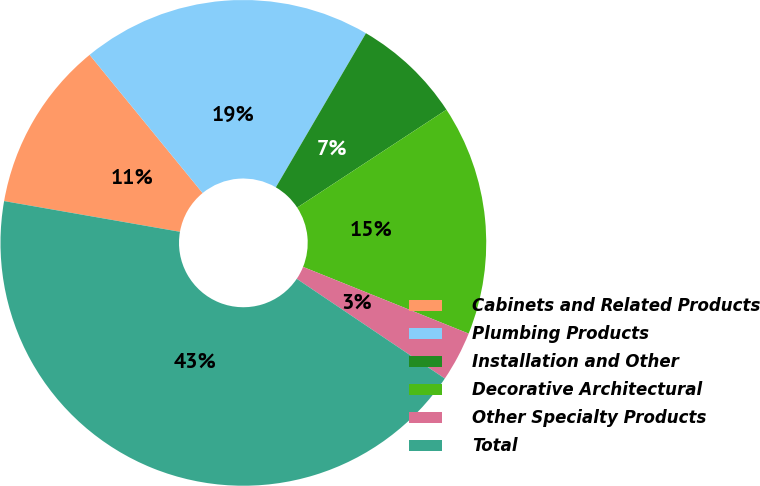<chart> <loc_0><loc_0><loc_500><loc_500><pie_chart><fcel>Cabinets and Related Products<fcel>Plumbing Products<fcel>Installation and Other<fcel>Decorative Architectural<fcel>Other Specialty Products<fcel>Total<nl><fcel>11.34%<fcel>19.33%<fcel>7.34%<fcel>15.33%<fcel>3.34%<fcel>43.32%<nl></chart> 